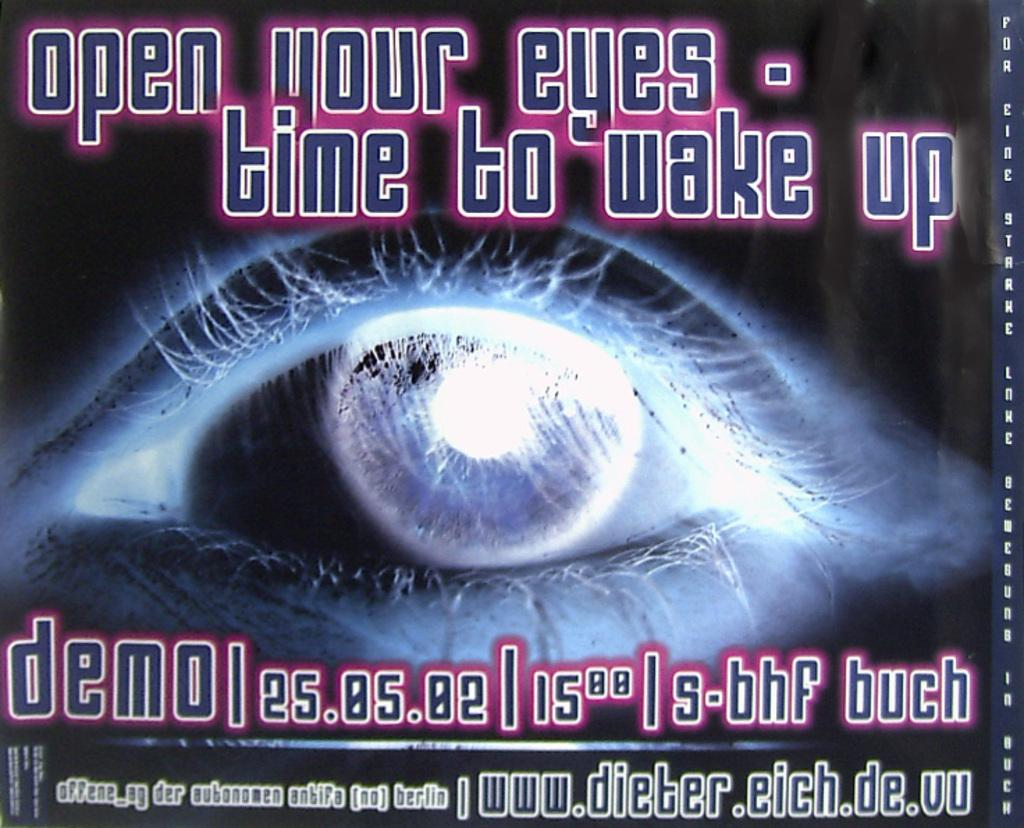What is the main subject of the image? The main subject of the image is an eye. What part of the eye is visible in the image? The pupil of the eye is visible in the image. Are there any additional details on the eye? Yes, there is writing on the eye. How many pizzas can be seen floating in the eye in the image? There are no pizzas present in the image; it features an eye with visible writing. Can you describe the behavior of the ducks in the image? There are no ducks present in the image; it features an eye with visible writing. 